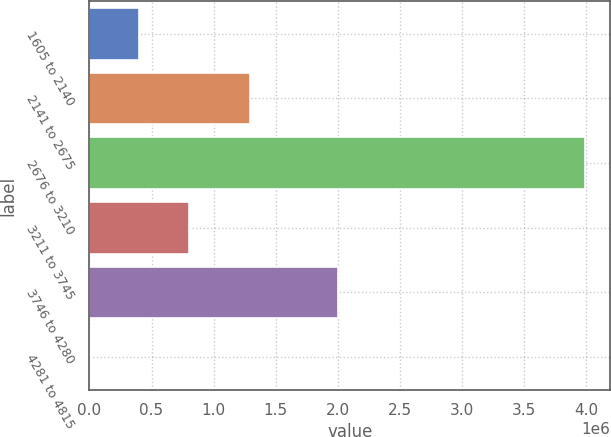Convert chart to OTSL. <chart><loc_0><loc_0><loc_500><loc_500><bar_chart><fcel>1605 to 2140<fcel>2141 to 2675<fcel>2676 to 3210<fcel>3211 to 3745<fcel>3746 to 4280<fcel>4281 to 4815<nl><fcel>402941<fcel>1.29039e+06<fcel>3.99253e+06<fcel>801784<fcel>2.00525e+06<fcel>4097<nl></chart> 